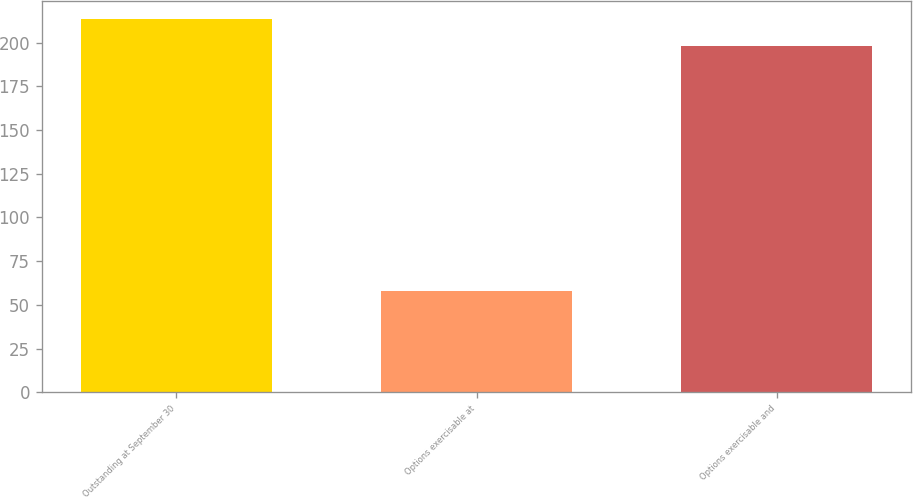Convert chart to OTSL. <chart><loc_0><loc_0><loc_500><loc_500><bar_chart><fcel>Outstanding at September 30<fcel>Options exercisable at<fcel>Options exercisable and<nl><fcel>213.4<fcel>58<fcel>198<nl></chart> 